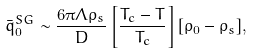<formula> <loc_0><loc_0><loc_500><loc_500>\bar { q } _ { 0 } ^ { S G } \sim \frac { 6 \pi \Lambda \rho _ { s } } { D } \left [ \frac { T _ { c } - T } { T _ { c } } \right ] [ \rho _ { 0 } - \rho _ { s } ] ,</formula> 